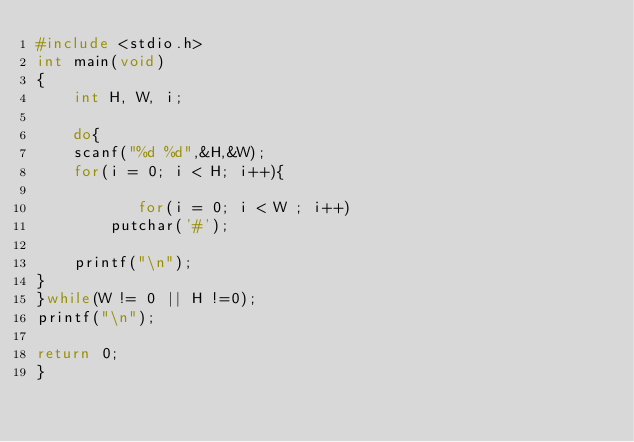Convert code to text. <code><loc_0><loc_0><loc_500><loc_500><_C_>#include <stdio.h>
int main(void)
{
	int H, W, i;
    
    do{
	scanf("%d %d",&H,&W);
	for(i = 0; i < H; i++){
	  
		   for(i = 0; i < W ; i++)
		putchar('#');
		   
	printf("\n");
}
}while(W != 0 || H !=0);
printf("\n");
		
return 0;
}</code> 